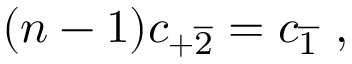<formula> <loc_0><loc_0><loc_500><loc_500>( n - 1 ) c _ { + \overline { 2 } } = c _ { \overline { 1 } } \ ,</formula> 